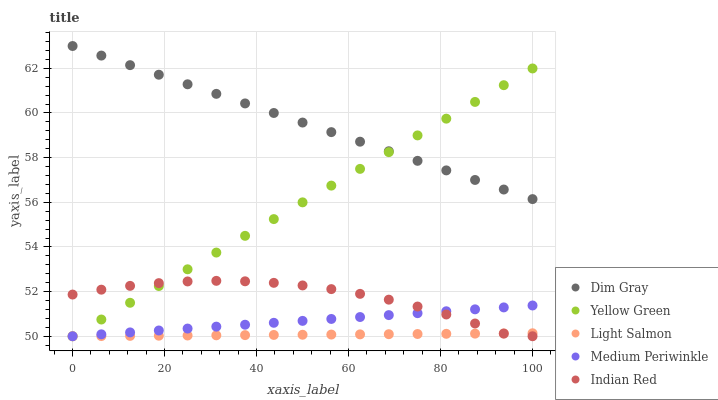Does Light Salmon have the minimum area under the curve?
Answer yes or no. Yes. Does Dim Gray have the maximum area under the curve?
Answer yes or no. Yes. Does Medium Periwinkle have the minimum area under the curve?
Answer yes or no. No. Does Medium Periwinkle have the maximum area under the curve?
Answer yes or no. No. Is Dim Gray the smoothest?
Answer yes or no. Yes. Is Indian Red the roughest?
Answer yes or no. Yes. Is Medium Periwinkle the smoothest?
Answer yes or no. No. Is Medium Periwinkle the roughest?
Answer yes or no. No. Does Light Salmon have the lowest value?
Answer yes or no. Yes. Does Dim Gray have the lowest value?
Answer yes or no. No. Does Dim Gray have the highest value?
Answer yes or no. Yes. Does Medium Periwinkle have the highest value?
Answer yes or no. No. Is Light Salmon less than Dim Gray?
Answer yes or no. Yes. Is Dim Gray greater than Light Salmon?
Answer yes or no. Yes. Does Yellow Green intersect Indian Red?
Answer yes or no. Yes. Is Yellow Green less than Indian Red?
Answer yes or no. No. Is Yellow Green greater than Indian Red?
Answer yes or no. No. Does Light Salmon intersect Dim Gray?
Answer yes or no. No. 